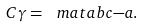<formula> <loc_0><loc_0><loc_500><loc_500>C \gamma = \ m a t { a } { b } { c } { - a } .</formula> 